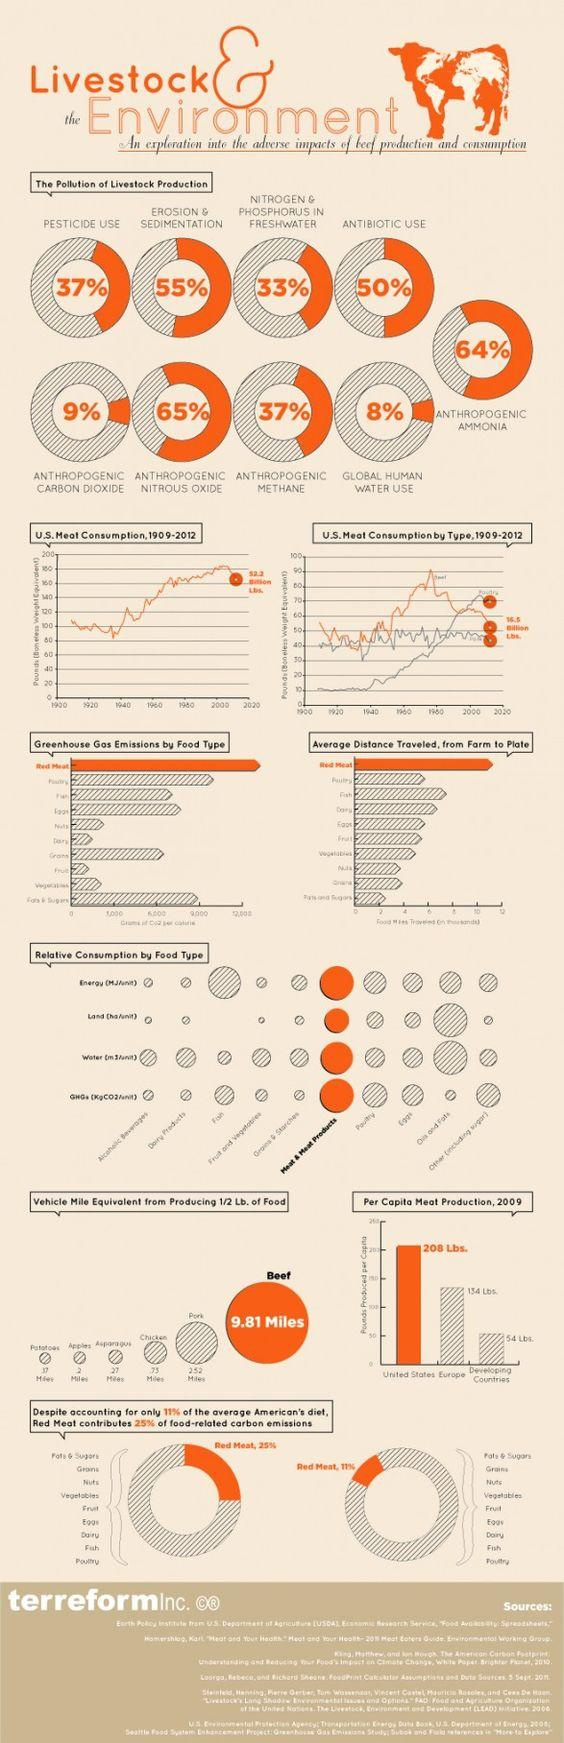Mention a couple of crucial points in this snapshot. Meat and meat products consume significantly more energy, water, and greenhouse gases than other food types. Pork is the food type that must travel the second longest distance to reach consumers, following only seafood. Antibiotic use in livestock production is responsible for 50% of pollution in this sector. The contribution of anthropogenic CH4, a greenhouse gas, to pollution from livestock production is significant, accounting for 37% of the total emissions. Red meat has the longest average distance traveled and the highest carbon emissions among all food types, according to the study. 